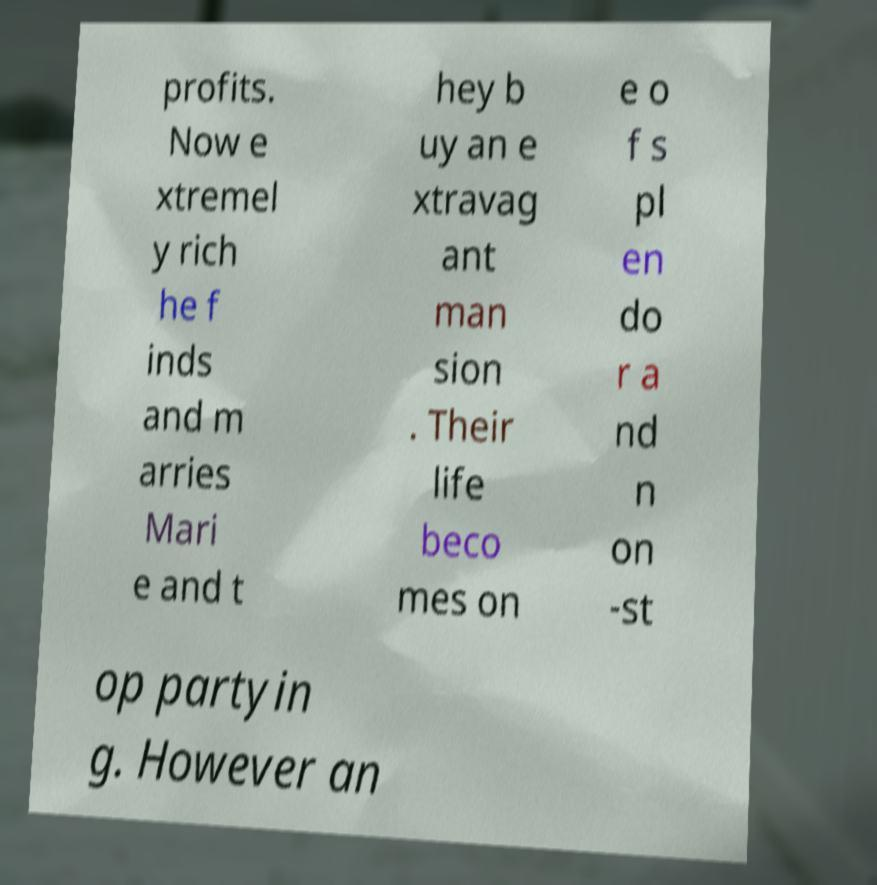I need the written content from this picture converted into text. Can you do that? profits. Now e xtremel y rich he f inds and m arries Mari e and t hey b uy an e xtravag ant man sion . Their life beco mes on e o f s pl en do r a nd n on -st op partyin g. However an 